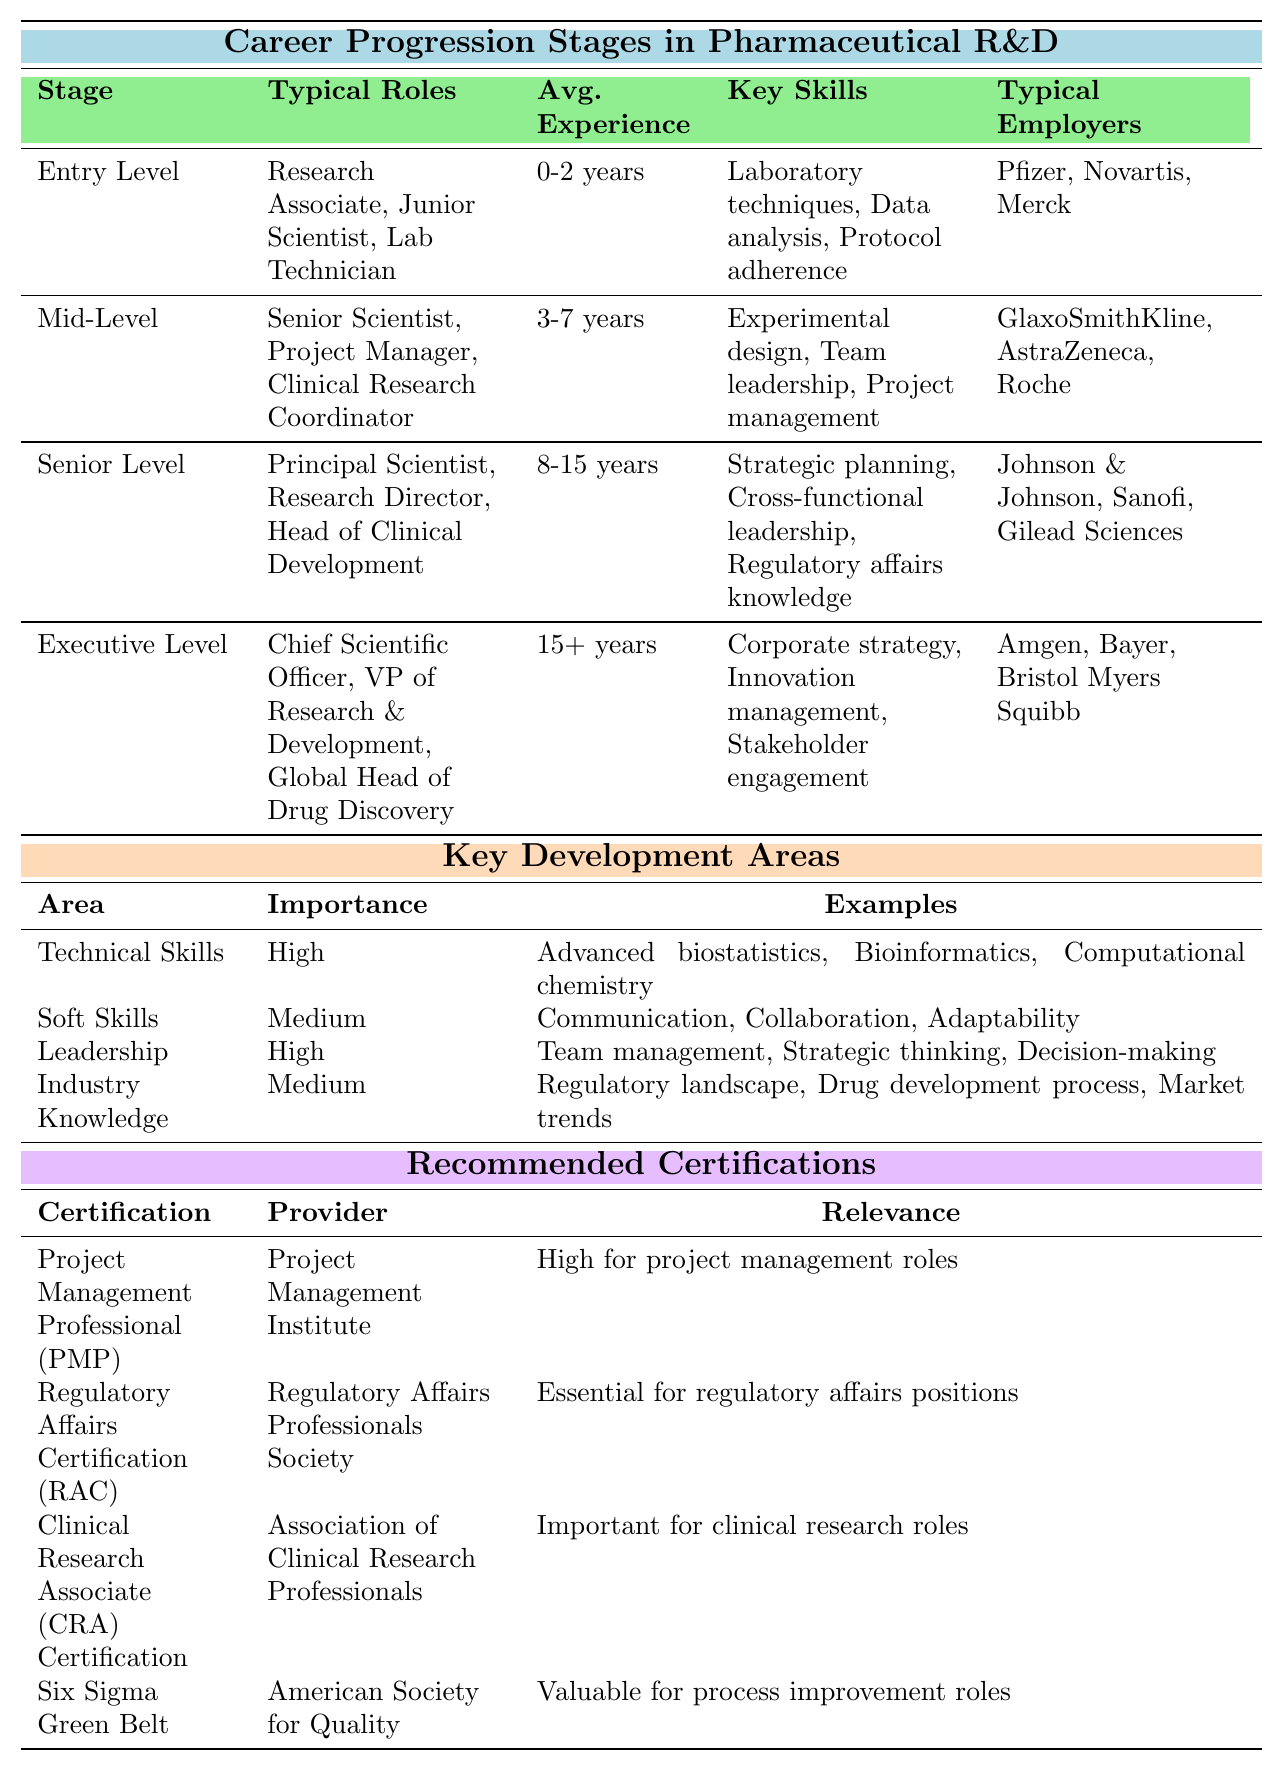What are the typical roles in the Entry Level stage? The table lists the typical roles under the Entry Level stage as Research Associate, Junior Scientist, and Lab Technician.
Answer: Research Associate, Junior Scientist, Lab Technician How many years of experience are generally expected for the Mid-Level stage? Under the Mid-Level stage, the table states that the average experience is 3-7 years.
Answer: 3-7 years Which key skills are required at the Senior Level? The table shows that key skills required at the Senior Level are Strategic planning, Cross-functional leadership, and Regulatory affairs knowledge.
Answer: Strategic planning, Cross-functional leadership, Regulatory affairs knowledge Is 'Team leadership' a key skill for Entry Level positions? The table indicates that Team leadership is listed as a key skill for Mid-Level positions, not for Entry Level positions.
Answer: No What is the importance level of Leadership as a key development area? The table shows that Leadership has a high importance level among the key development areas.
Answer: High Which typical employers are associated with the Executive Level stage? According to the table, typical employers at the Executive Level include Amgen, Bayer, and Bristol Myers Squibb.
Answer: Amgen, Bayer, Bristol Myers Squibb Among the Key Development Areas, which one has a medium importance level? The table states that both Soft Skills and Industry Knowledge have a medium importance rating.
Answer: Soft Skills, Industry Knowledge Which certification is essential for regulatory affairs positions? The table specifies that the Regulatory Affairs Certification (RAC) is essential for regulatory affairs positions.
Answer: Regulatory Affairs Certification (RAC) What is the average experience needed for a Chief Scientific Officer? The table indicates that a Chief Scientific Officer typically requires 15+ years of experience.
Answer: 15+ years Is the Regulatory landscape part of the examples listed under Industry Knowledge? Yes, the table explicitly mentions Regulatory landscape as one of the examples under Industry Knowledge.
Answer: Yes Which stage has roles requiring the least amount of experience? Observing the average experience levels, the Entry Level stage requires the least amount of experience at 0-2 years.
Answer: Entry Level How many typical roles were listed for the Mid-Level stage? The table lists three typical roles under the Mid-Level stage: Senior Scientist, Project Manager, and Clinical Research Coordinator.
Answer: Three roles What are the examples listed under Technical Skills? The examples under Technical Skills are Advanced biostatistics, Bioinformatics, and Computational chemistry according to the table.
Answer: Advanced biostatistics, Bioinformatics, Computational chemistry Which certification is relevant for process improvement roles? The table notes that the Six Sigma Green Belt certification is valuable for process improvement roles.
Answer: Six Sigma Green Belt What can be inferred about the transition from Entry Level to Mid-Level? The transition requires gaining experience and developing new key skills such as Experimental design and Project management, which are crucial for Mid-Level roles.
Answer: Gaining experience and developing new key skills 